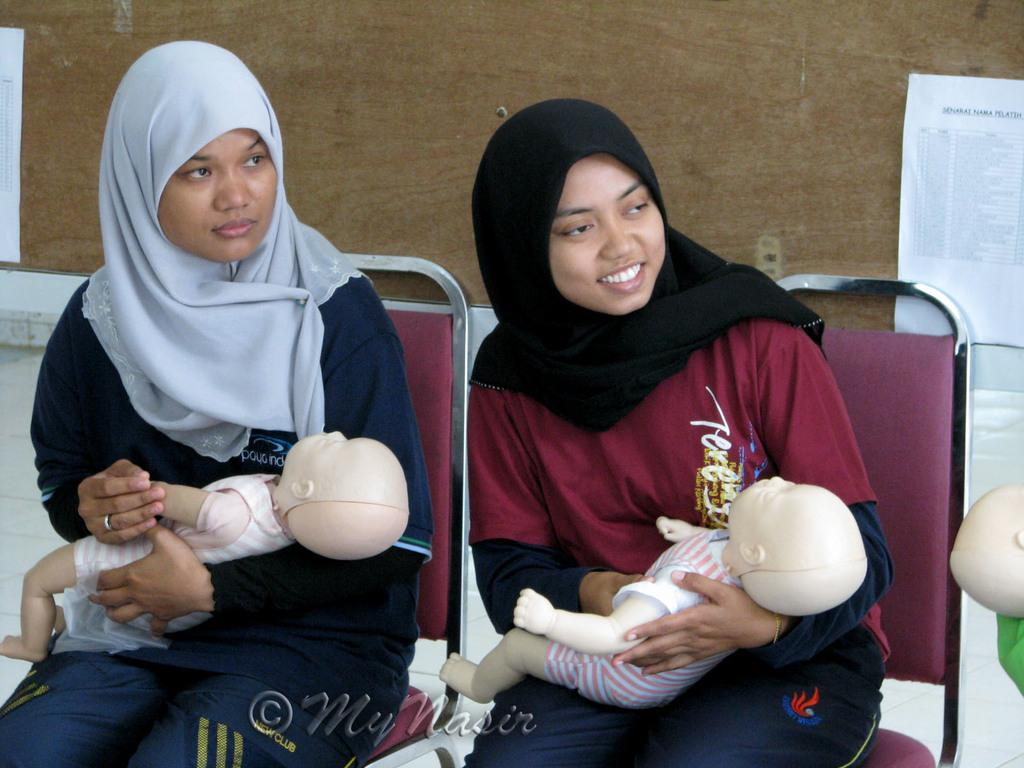How many people are in the image? There are two ladies in the image. What are the ladies doing in the image? The ladies are sitting on chairs and holding toys. What can be seen in the background of the image? There is a wall in the background of the image. What is on the wall? There are papers on the wall, and there is text on the papers. What type of meal is being prepared in the image? There is no meal preparation visible in the image; the ladies are holding toys and sitting on chairs. Can you tell me how much milk is being poured in the image? There is no milk or pouring action present in the image. 